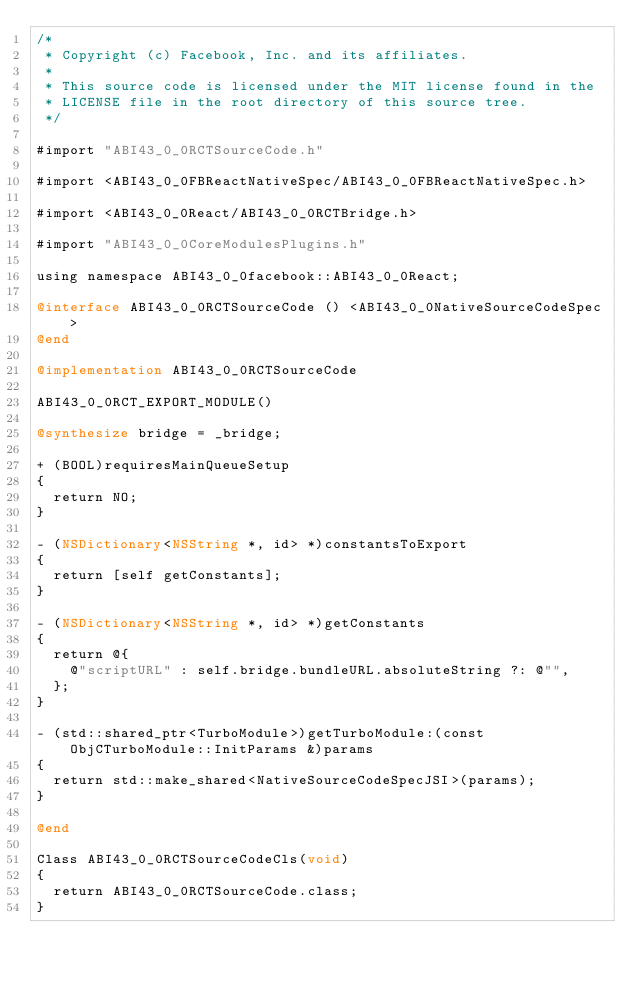Convert code to text. <code><loc_0><loc_0><loc_500><loc_500><_ObjectiveC_>/*
 * Copyright (c) Facebook, Inc. and its affiliates.
 *
 * This source code is licensed under the MIT license found in the
 * LICENSE file in the root directory of this source tree.
 */

#import "ABI43_0_0RCTSourceCode.h"

#import <ABI43_0_0FBReactNativeSpec/ABI43_0_0FBReactNativeSpec.h>

#import <ABI43_0_0React/ABI43_0_0RCTBridge.h>

#import "ABI43_0_0CoreModulesPlugins.h"

using namespace ABI43_0_0facebook::ABI43_0_0React;

@interface ABI43_0_0RCTSourceCode () <ABI43_0_0NativeSourceCodeSpec>
@end

@implementation ABI43_0_0RCTSourceCode

ABI43_0_0RCT_EXPORT_MODULE()

@synthesize bridge = _bridge;

+ (BOOL)requiresMainQueueSetup
{
  return NO;
}

- (NSDictionary<NSString *, id> *)constantsToExport
{
  return [self getConstants];
}

- (NSDictionary<NSString *, id> *)getConstants
{
  return @{
    @"scriptURL" : self.bridge.bundleURL.absoluteString ?: @"",
  };
}

- (std::shared_ptr<TurboModule>)getTurboModule:(const ObjCTurboModule::InitParams &)params
{
  return std::make_shared<NativeSourceCodeSpecJSI>(params);
}

@end

Class ABI43_0_0RCTSourceCodeCls(void)
{
  return ABI43_0_0RCTSourceCode.class;
}
</code> 